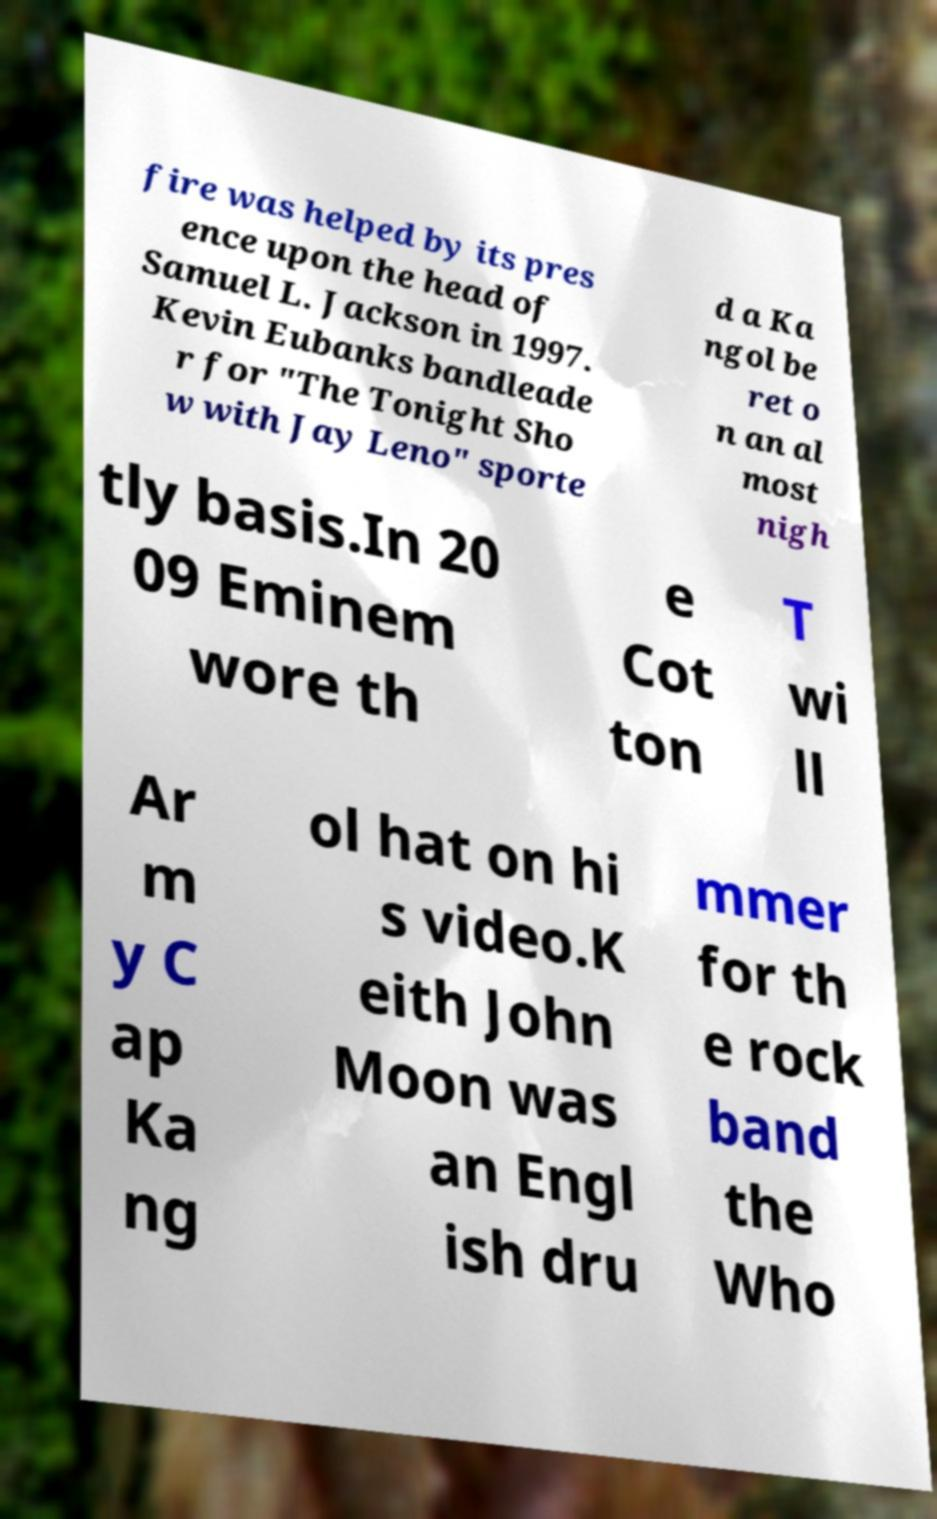Please read and relay the text visible in this image. What does it say? fire was helped by its pres ence upon the head of Samuel L. Jackson in 1997. Kevin Eubanks bandleade r for "The Tonight Sho w with Jay Leno" sporte d a Ka ngol be ret o n an al most nigh tly basis.In 20 09 Eminem wore th e Cot ton T wi ll Ar m y C ap Ka ng ol hat on hi s video.K eith John Moon was an Engl ish dru mmer for th e rock band the Who 